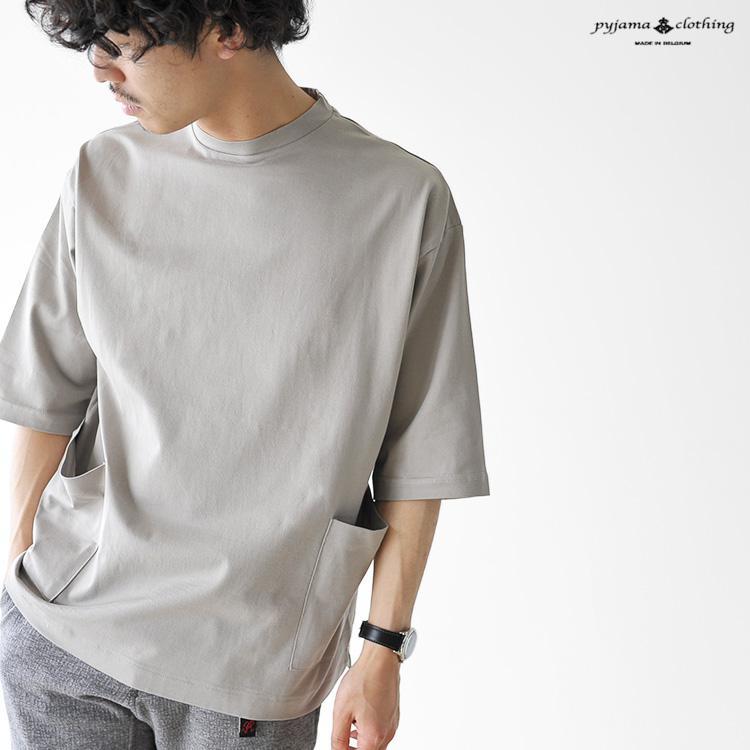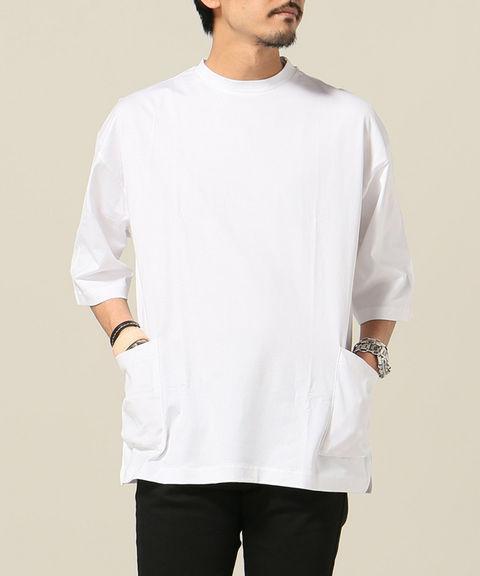The first image is the image on the left, the second image is the image on the right. Considering the images on both sides, is "The man in the left image is wearing a hat." valid? Answer yes or no. No. The first image is the image on the left, the second image is the image on the right. For the images shown, is this caption "One man is wearing something on his head." true? Answer yes or no. No. 